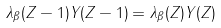Convert formula to latex. <formula><loc_0><loc_0><loc_500><loc_500>\lambda _ { \beta } ( Z - 1 ) Y ( Z - 1 ) = \lambda _ { \beta } ( Z ) Y ( Z )</formula> 